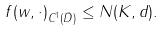Convert formula to latex. <formula><loc_0><loc_0><loc_500><loc_500>\| f ( w , \cdot ) \| _ { C ^ { 1 } ( { \bar { D } } ) } \leq N ( K , d ) .</formula> 